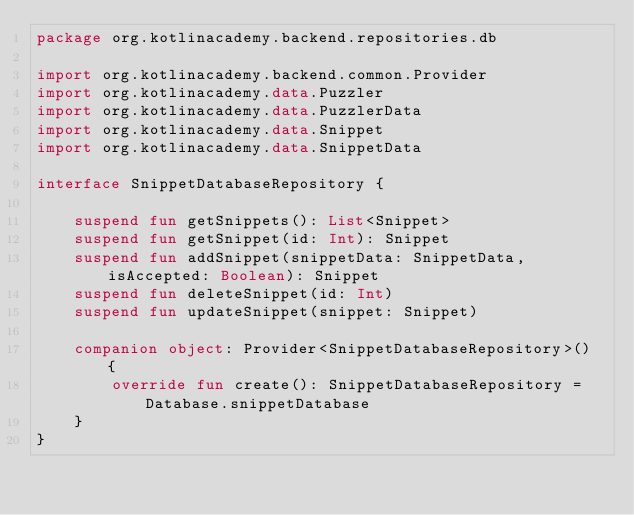<code> <loc_0><loc_0><loc_500><loc_500><_Kotlin_>package org.kotlinacademy.backend.repositories.db

import org.kotlinacademy.backend.common.Provider
import org.kotlinacademy.data.Puzzler
import org.kotlinacademy.data.PuzzlerData
import org.kotlinacademy.data.Snippet
import org.kotlinacademy.data.SnippetData

interface SnippetDatabaseRepository {

    suspend fun getSnippets(): List<Snippet>
    suspend fun getSnippet(id: Int): Snippet
    suspend fun addSnippet(snippetData: SnippetData, isAccepted: Boolean): Snippet
    suspend fun deleteSnippet(id: Int)
    suspend fun updateSnippet(snippet: Snippet)

    companion object: Provider<SnippetDatabaseRepository>() {
        override fun create(): SnippetDatabaseRepository = Database.snippetDatabase
    }
}</code> 